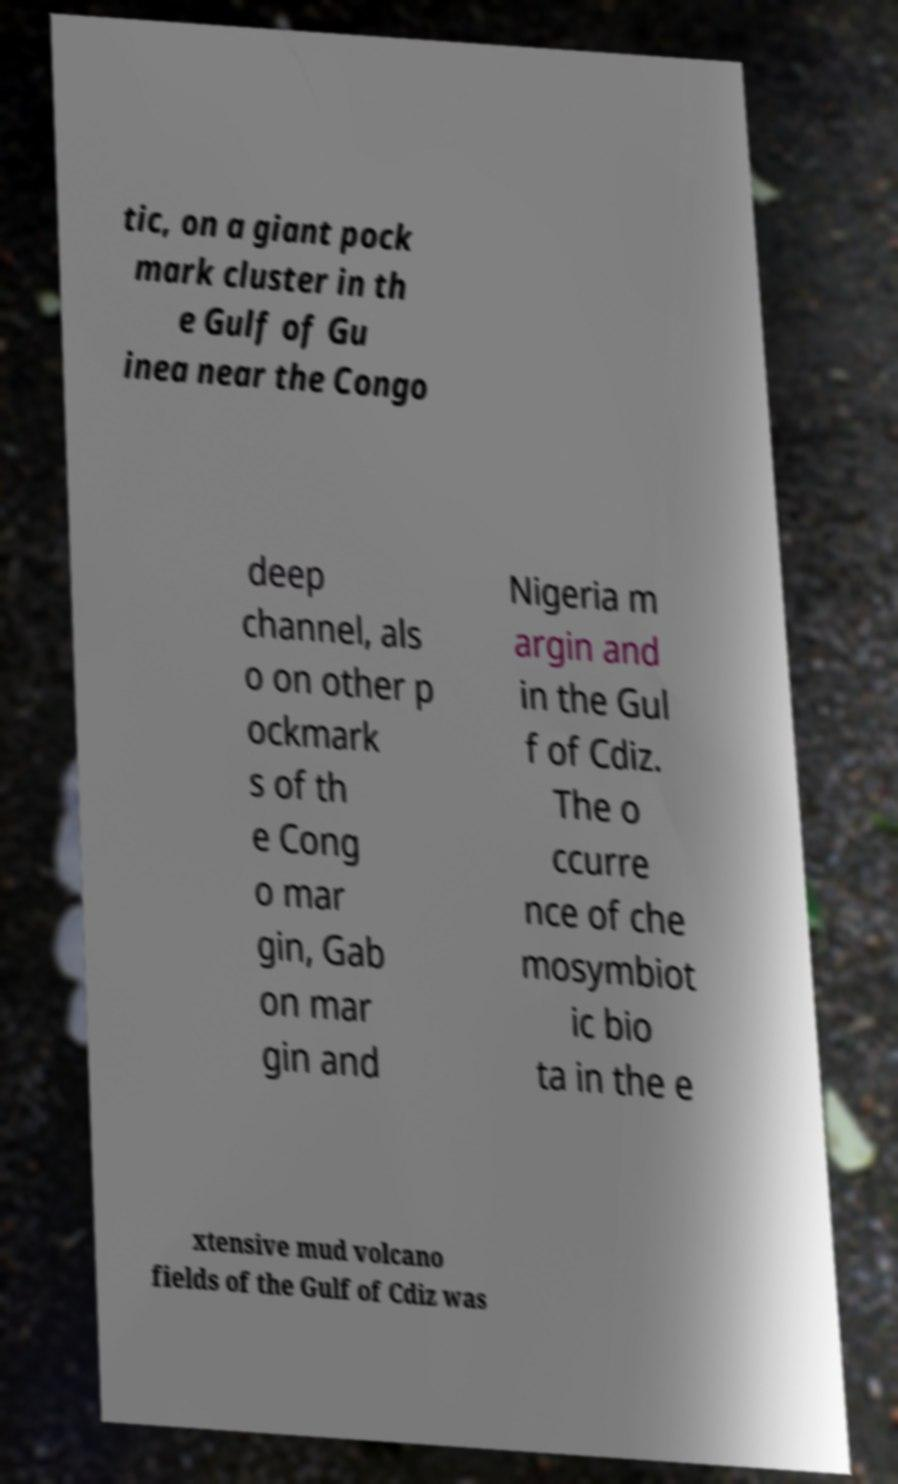Could you extract and type out the text from this image? tic, on a giant pock mark cluster in th e Gulf of Gu inea near the Congo deep channel, als o on other p ockmark s of th e Cong o mar gin, Gab on mar gin and Nigeria m argin and in the Gul f of Cdiz. The o ccurre nce of che mosymbiot ic bio ta in the e xtensive mud volcano fields of the Gulf of Cdiz was 